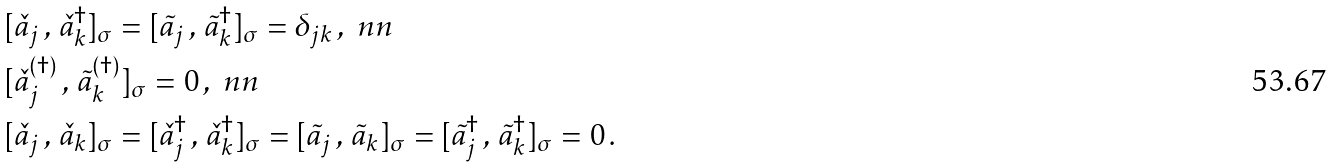<formula> <loc_0><loc_0><loc_500><loc_500>& [ { \check { a } } _ { j } \, , \, { \check { a } } _ { k } ^ { \dagger } ] _ { \sigma } = [ { \tilde { a } } _ { j } \, , \, { \tilde { a } } _ { k } ^ { \dagger } ] _ { \sigma } = \delta _ { j k } \, , \ n n \\ & [ { \check { a } } _ { j } ^ { ( \dagger ) } \, , \, { \tilde { a } } _ { k } ^ { ( \dagger ) } ] _ { \sigma } = 0 \, , \ n n \\ & [ { \check { a } } _ { j } \, , \, { \check { a } } _ { k } ] _ { \sigma } = [ { \check { a } } _ { j } ^ { \dagger } \, , \, { \check { a } } _ { k } ^ { \dagger } ] _ { \sigma } = [ { \tilde { a } } _ { j } \, , \, { \tilde { a } } _ { k } ] _ { \sigma } = [ { \tilde { a } } _ { j } ^ { \dagger } \, , \, { \tilde { a } } _ { k } ^ { \dagger } ] _ { \sigma } = 0 \, .</formula> 